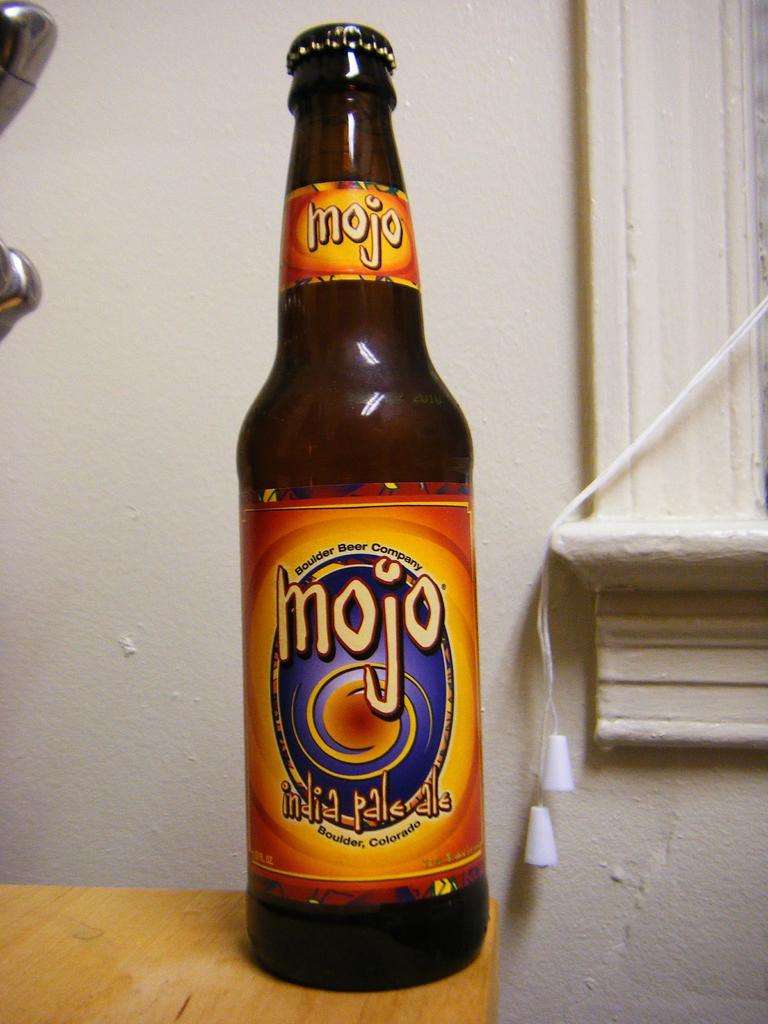Where does this drink originate?
Your answer should be compact. Boulder, colorado. What is this called?
Offer a very short reply. Mojo. 